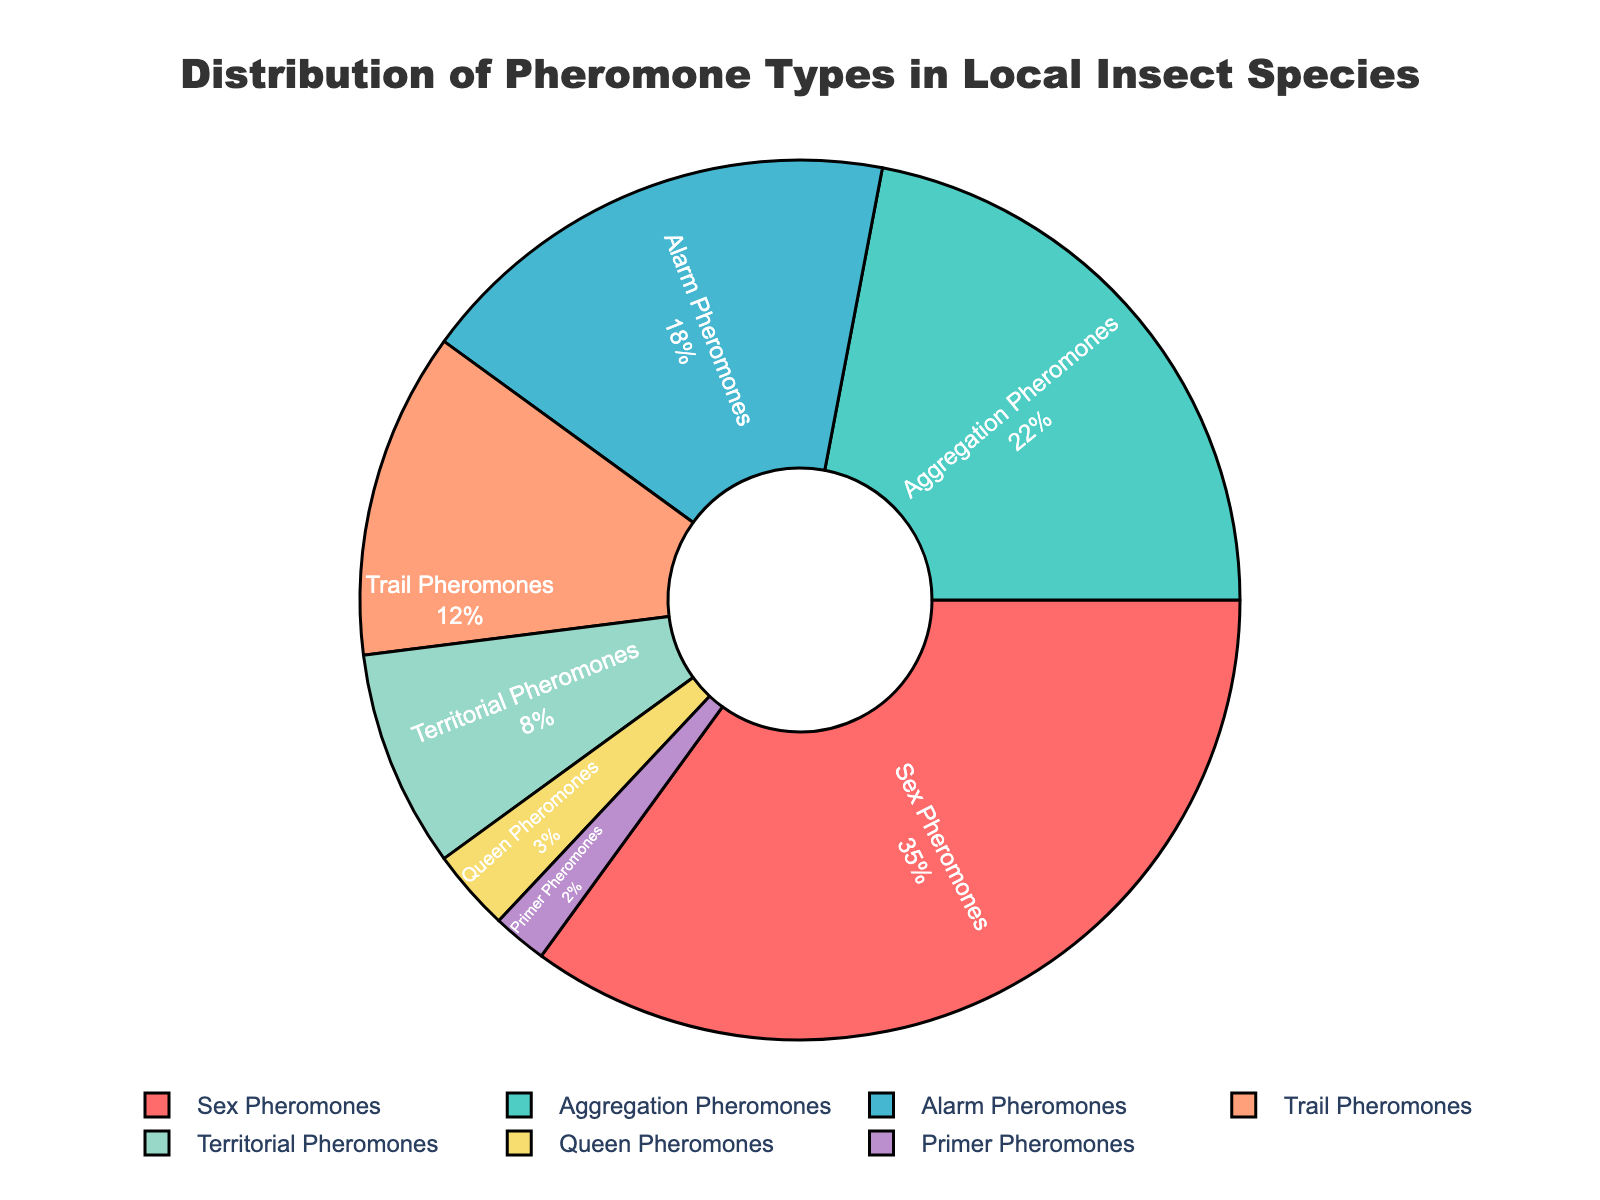What pheromone type makes up the highest percentage in local insect species? By looking at the pie chart, we can see that the largest section is labeled "Sex Pheromones," which is colored in red. The percentage shown for this section is 35%. Therefore, "Sex Pheromones" makes up the highest percentage.
Answer: Sex Pheromones Which two pheromone types together make up 30% of the distribution? We observe the chart to find two sections whose combined percentages add up to 30%. "Territorial Pheromones" (8%) and "Trail Pheromones" (12%) together make 20%, and adding "Queen Pheromones" (3%) gives 23%. The next valid pair is "Alarm Pheromones" (18%) and "Trail Pheromones" (12%), which together make 30%.
Answer: Alarm Pheromones and Trail Pheromones Which pheromone types have a combined percentage equal to the percentage of Sex Pheromones? "Sex Pheromones" account for 35%. Identifying a combination of other pheromone types that add up to the same percentage gives us "Aggregation Pheromones" (22%) and "Alarm Pheromones" (18%). Their combined sum is 22 + 18 = 40, not equal to 35. Hence, "Alarm Pheromones" (18%) plus "Trail Pheromones" (12%) plus "Territorial Pheromones" (8%) sums to 38%, not valid. Finally, "Aggregation Pheromones," "Trail Pheromones," and "Queen Pheromones" sum to 22 + 12 + 3 = 37%. Thus, we can't directly combine any numbers to match "Sex Pheromones."
Answer: None What is the ratio of Sex Pheromones to Alarm Pheromones? According to the pie chart, "Sex Pheromones" makes up 35% while "Alarm Pheromones" account for 18%. The ratio can be found by dividing 35 by 18, which simplifies to approximately 1.94. Therefore, the ratio is 35:18.
Answer: 1.94:1 What percent of the distribution is made up by pheromones types other than Sex Pheromones? The total percentage of the chart is 100%. Subtract the percentage of "Sex Pheromones" (35%) from the total to find the sum of the other pheromone types. The calculation is 100 - 35 = 65. Thus, the remaining pheromone types together make up 65% of the distribution.
Answer: 65% Which two pheromone types have the smallest combined percentage? From the pie chart, the smallest percentages are "Primer Pheromones" (2%) and "Queen Pheromones" (3%). Adding these two values together gives 2 + 3 = 5. Therefore, "Primer Pheromones" and "Queen Pheromones" have the smallest combined percentage.
Answer: Primer Pheromones and Queen Pheromones If these percentages were evenly distributed among 5 insect species, how much percentage would each species get for Sex Pheromones? "Sex Pheromones" have a percentage of 35%. If this percentage is divided evenly among 5 insect species, we perform the calculation 35 / 5 = 7. Thus, each species would get 7%.
Answer: 7% How much more prevalent are Aggregation Pheromones compared to Queen Pheromones? The percentage for "Aggregation Pheromones" is 22%, while that for "Queen Pheromones" is 3%. To find how much more prevalent the former is compared to the latter, we subtract the smaller percentage from the larger one: 22 - 3 = 19. Therefore, "Aggregation Pheromones" are 19% more prevalent.
Answer: 19% Arrange the pheromone types in descending order of their percentages. Analyzing the percentages given in the pie chart: "Sex Pheromones" (35%), "Aggregation Pheromones" (22%), "Alarm Pheromones" (18%), "Trail Pheromones" (12%), "Territorial Pheromones" (8%), "Queen Pheromones" (3%), and "Primer Pheromones" (2%). Sorting these from highest to lowest gives us: "Sex Pheromones," "Aggregation Pheromones," "Alarm Pheromones," "Trail Pheromones," "Territorial Pheromones," "Queen Pheromones," and "Primer Pheromones."
Answer: Sex Pheromones, Aggregation Pheromones, Alarm Pheromones, Trail Pheromones, Territorial Pheromones, Queen Pheromones, Primer Pheromones 